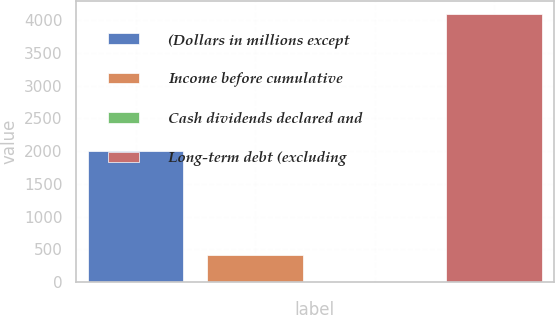Convert chart to OTSL. <chart><loc_0><loc_0><loc_500><loc_500><bar_chart><fcel>(Dollars in millions except<fcel>Income before cumulative<fcel>Cash dividends declared and<fcel>Long-term debt (excluding<nl><fcel>2007<fcel>411.33<fcel>1.92<fcel>4088<nl></chart> 